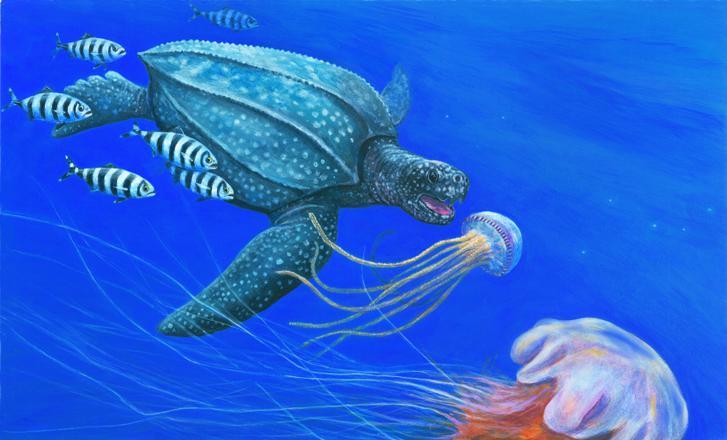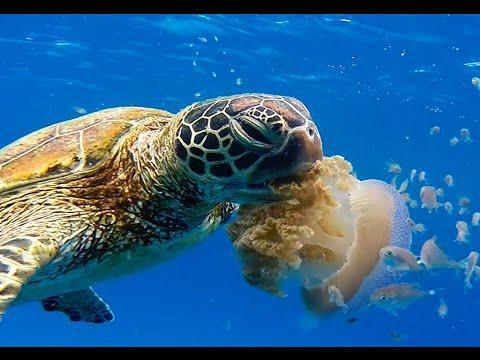The first image is the image on the left, the second image is the image on the right. For the images displayed, is the sentence "There are no more than six fish swimming next to a turtle." factually correct? Answer yes or no. Yes. The first image is the image on the left, the second image is the image on the right. Assess this claim about the two images: "a turtle is taking a bite of a pink jellyfish". Correct or not? Answer yes or no. No. 